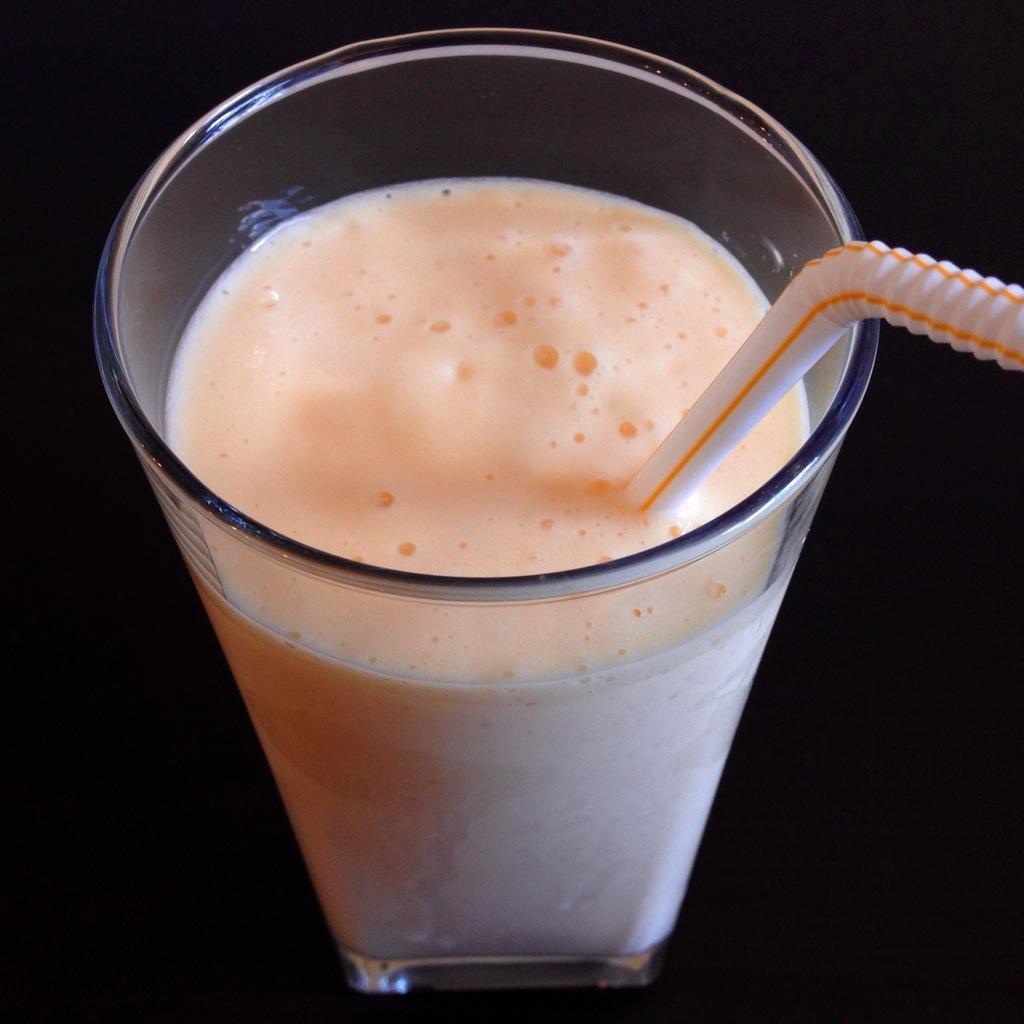In one or two sentences, can you explain what this image depicts? In this image, we can see a glass with liquid and straw. This glass is placed on the black surface. 